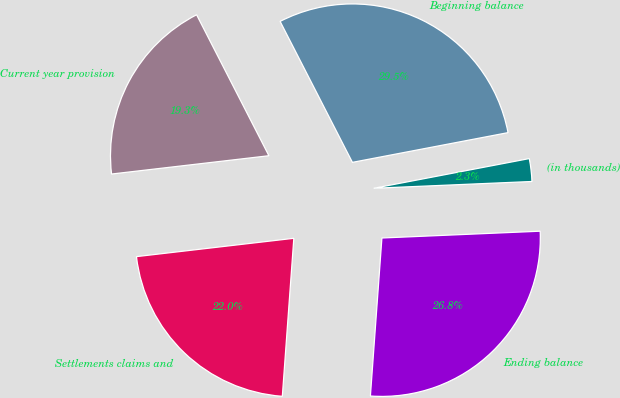Convert chart to OTSL. <chart><loc_0><loc_0><loc_500><loc_500><pie_chart><fcel>(in thousands)<fcel>Beginning balance<fcel>Current year provision<fcel>Settlements claims and<fcel>Ending balance<nl><fcel>2.32%<fcel>29.54%<fcel>19.3%<fcel>22.0%<fcel>26.84%<nl></chart> 